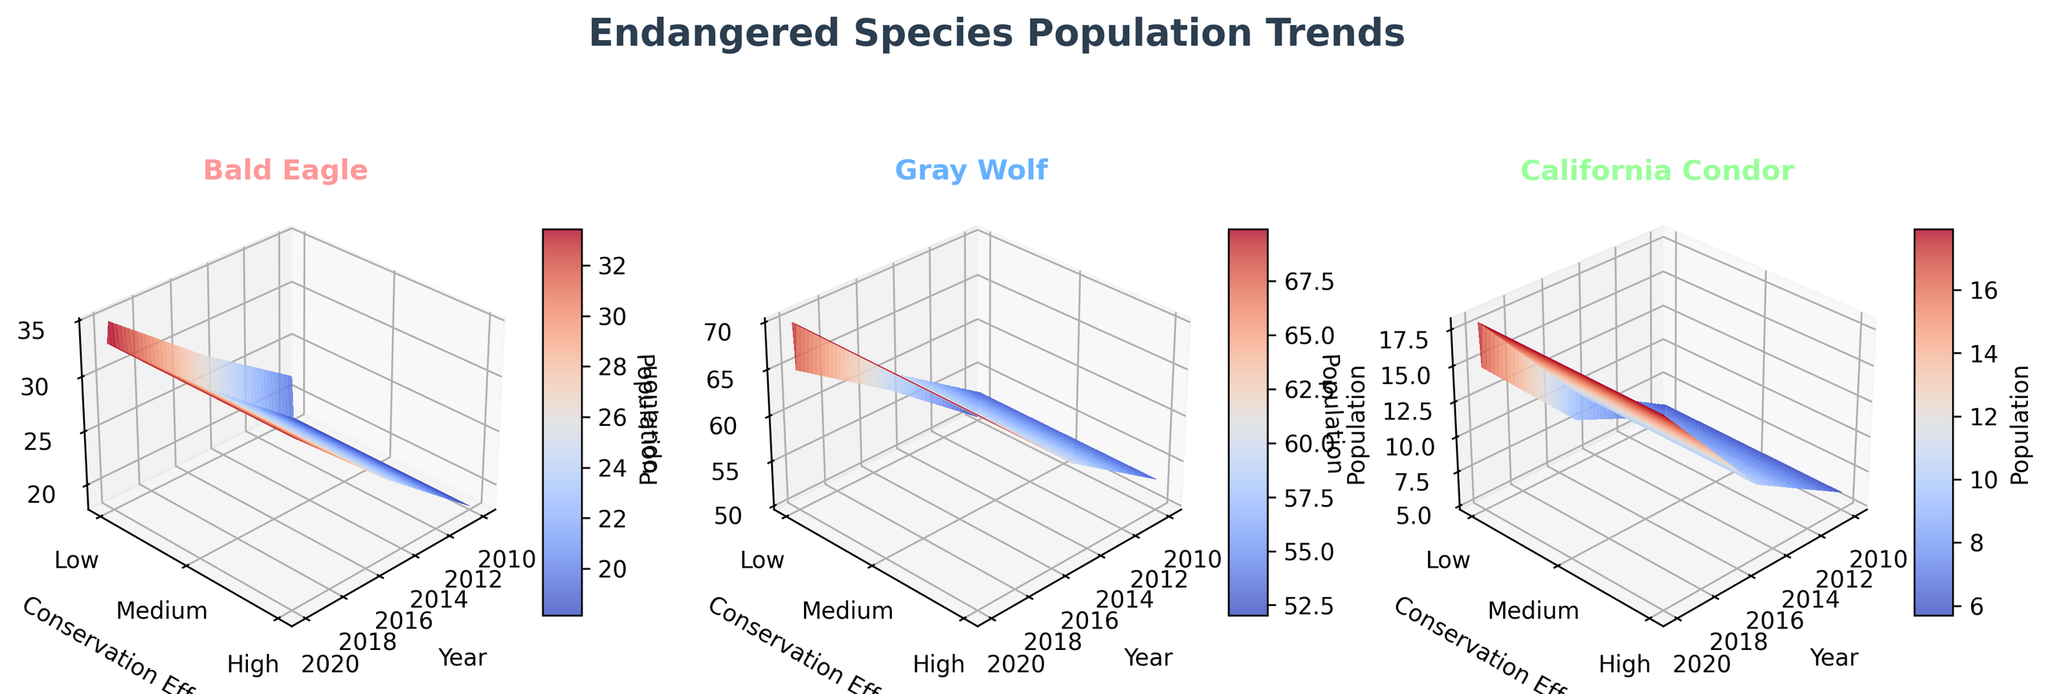What's the main title of the figure? The main title of the figure is centrally located at the top and states the overall theme of the figure.
Answer: Endangered Species Population Trends How many subplots are there in the figure? The figure is divided into multiple panels, and each panel represents different species.
Answer: 3 What species are shown in the subplots? The title of each subplot provides the name of the species it represents.
Answer: Bald Eagle, Gray Wolf, and California Condor How does population change over time for the Bald Eagle in Yellowstone? Inspect the subplot for Bald Eagle and observe the trend along the year axis for the specific reserve.
Answer: It increases Which species shows the most significant population increase with higher conservation effort? Compare the slopes of the surfaces in the subplots, focusing on the z-axis changes corresponding to higher conservation efforts (y-axis).
Answer: California Condor What is the trend in population for Gray Wolf in the Rocky Mountain reserve from 2010 to 2020? Analyze the subplot of Gray Wolf, focusing on the specific reserve and note the changes in the z-axis over the years.
Answer: It increases Which year has the lowest population for California Condor in Sequoia? Look at the California Condor subplot and check the population value (z-axis) for different years within Sequoia.
Answer: 2010 Between Bald Eagle and Gray Wolf, which species has a higher population in 2020 in Yellowstone? Compare the population values in 2020 on the z-axis for both species within the Yellowstone reserve.
Answer: Gray Wolf What conservation effort level corresponds to the highest population of Bald Eagle in Yosemite? In the Bald Eagle subplot, find the highest population value on the z-axis and note the corresponding conservation effort on the y-axis.
Answer: High How does the population of California Condor in Grand Canyon change with increased conservation efforts? Observe the California Condor subplot, specifically how the z-axis values (population) change along the conservation effort y-axis from low to high.
Answer: It increases 